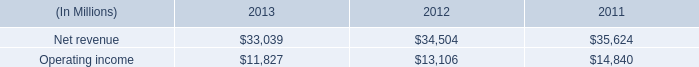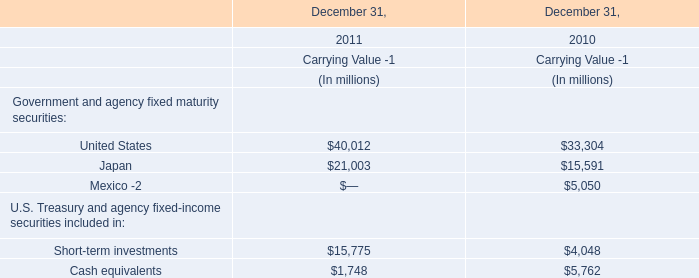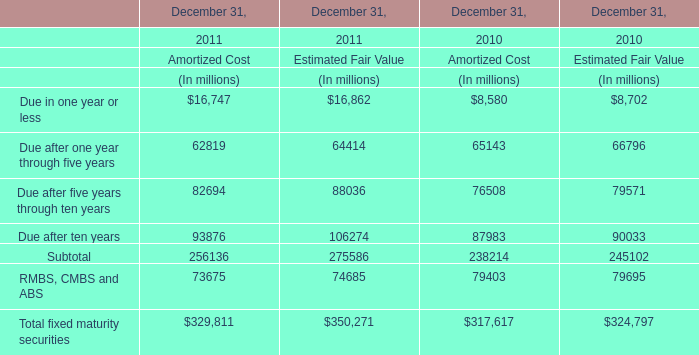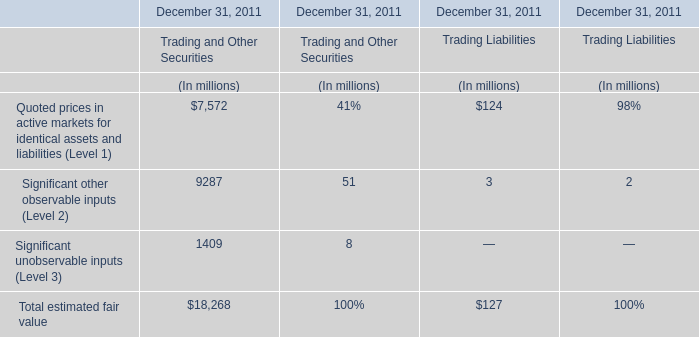What is the growing rate of Due after ten years in the year with the most Due after five years through ten years? 
Computations: (((93876 + 106274) - (87983 + 90033)) / (93876 + 106274))
Answer: 0.11059. 